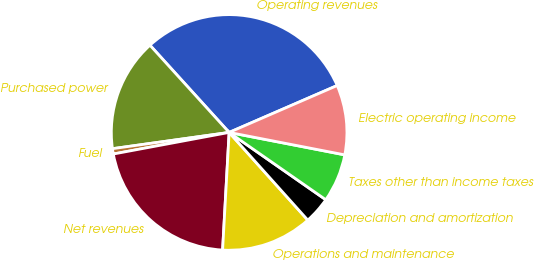Convert chart to OTSL. <chart><loc_0><loc_0><loc_500><loc_500><pie_chart><fcel>Operating revenues<fcel>Purchased power<fcel>Fuel<fcel>Net revenues<fcel>Operations and maintenance<fcel>Depreciation and amortization<fcel>Taxes other than income taxes<fcel>Electric operating income<nl><fcel>30.21%<fcel>15.47%<fcel>0.73%<fcel>21.18%<fcel>12.52%<fcel>3.68%<fcel>6.63%<fcel>9.57%<nl></chart> 